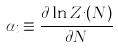Convert formula to latex. <formula><loc_0><loc_0><loc_500><loc_500>\alpha _ { i } \equiv \frac { \partial \ln Z _ { i } ( N ) } { \partial N }</formula> 